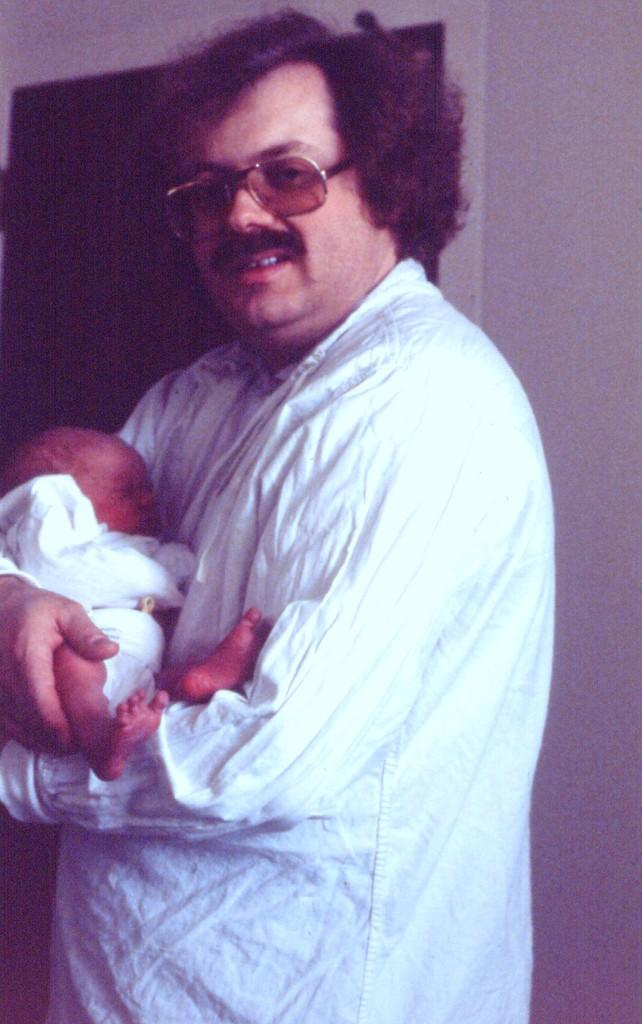Who is present in the image? There is a man in the image. What is the man doing in the image? The man is standing in the image. What is the man holding in his hands? The man is holding a baby in his hands. What type of clam can be seen on the man's desk in the image? There is no clam present in the image, and the man does not have a desk. 